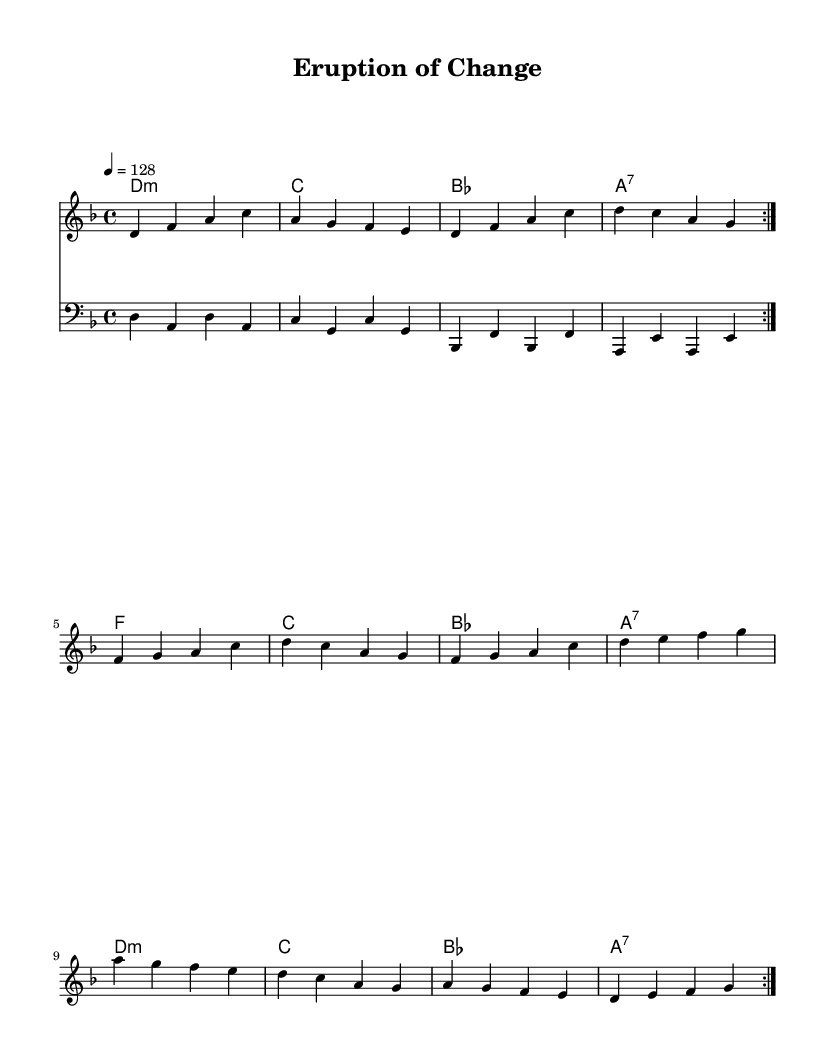What is the key signature of this music? The key signature indicated is D minor, which has one flat (B flat).
Answer: D minor What is the time signature of this piece? The time signature displayed is 4/4, which means there are four beats in each measure.
Answer: 4/4 What is the tempo marking of the music? The tempo marking is indicated as "4 = 128", meaning the quarter note gets a beat of 128 beats per minute.
Answer: 128 How many measures are repeated in the melody? The melody indicates a repeat sign for two complete measures, which shows that these measures should be played twice.
Answer: 2 What type of chords are primarily used in the harmonies? The harmonies mainly consist of minor and seventh chords, typical for creating emotional depth in music.
Answer: Minor and seventh chords What is the genre of this piece? The style of this music, indicated by its structure and themes, is K-Pop, which often emphasizes catchy melodies and danceable rhythms.
Answer: K-Pop What environmental theme can be inferred from the title "Eruption of Change"? The title suggests a focus on both natural disasters, like volcanic eruptions, and the broader concept of change related to the environment.
Answer: Environmental conservation 